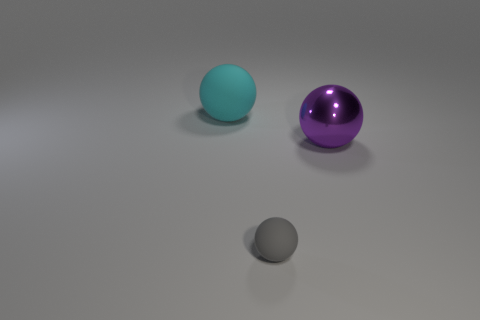There is a sphere that is left of the big metal thing and on the right side of the cyan rubber thing; what color is it?
Your answer should be compact. Gray. Are there an equal number of small gray matte objects that are right of the tiny gray thing and gray rubber objects that are behind the large purple shiny sphere?
Give a very brief answer. Yes. What is the color of the thing that is made of the same material as the small sphere?
Your answer should be compact. Cyan. There is a rubber thing behind the matte thing that is in front of the large purple sphere; are there any objects in front of it?
Make the answer very short. Yes. There is a gray object that is the same material as the large cyan sphere; what shape is it?
Provide a succinct answer. Sphere. Is the number of tiny balls that are in front of the purple metal thing greater than the number of gray balls that are in front of the tiny gray sphere?
Provide a short and direct response. Yes. What number of other objects are there of the same size as the cyan matte ball?
Your answer should be compact. 1. Do the gray object and the big thing that is in front of the cyan ball have the same shape?
Provide a succinct answer. Yes. How many matte things are cyan objects or gray spheres?
Give a very brief answer. 2. Are any small brown spheres visible?
Provide a succinct answer. No. 